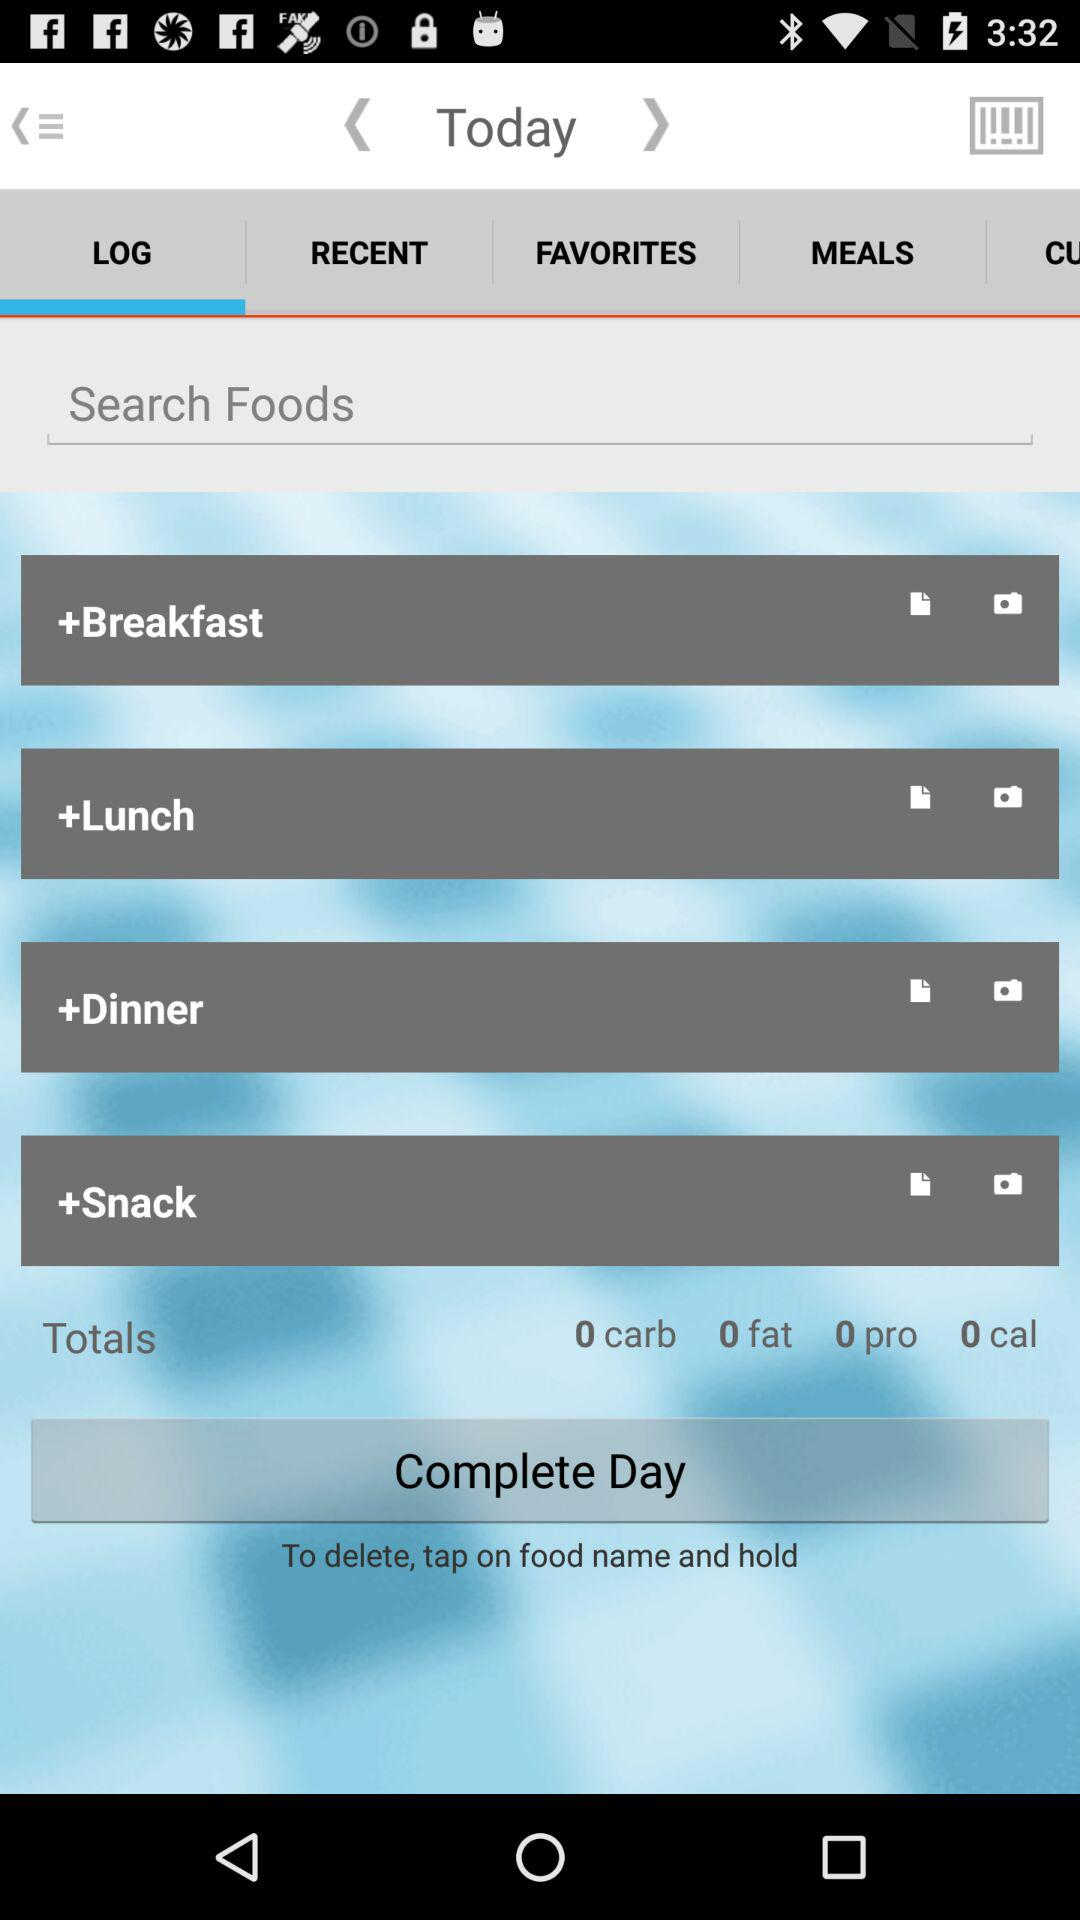What is the selected tab? The selected tab is "LOG". 